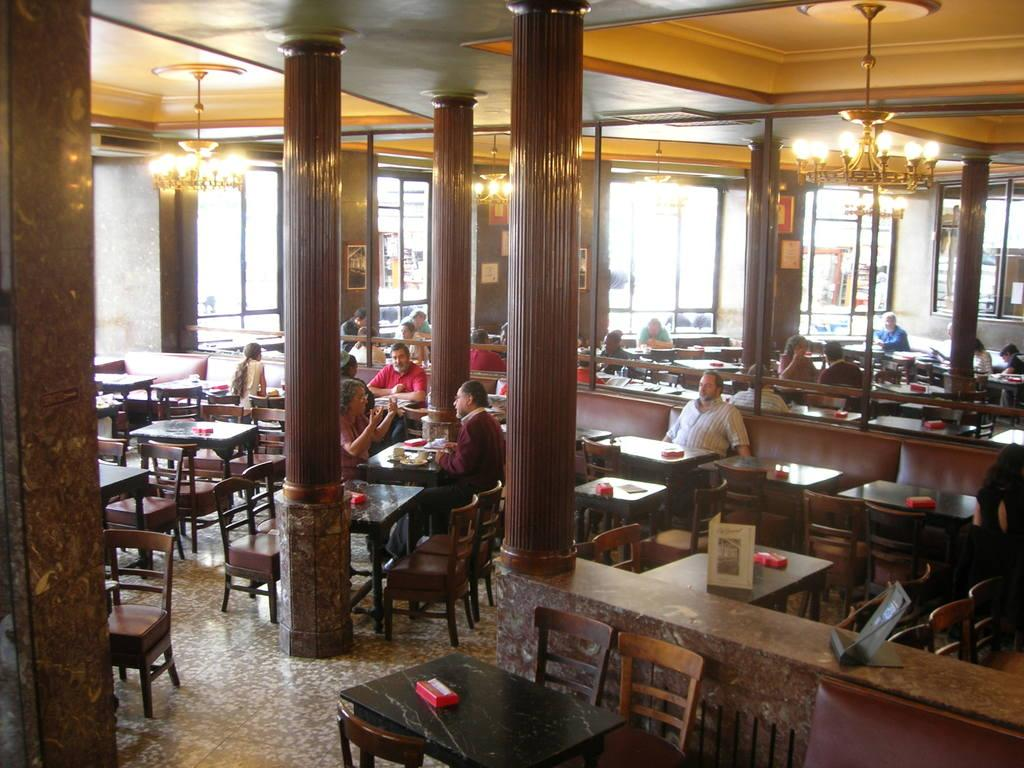What are the persons in the image doing? The persons in the image are sitting in chairs. What can be seen in the background of the image? There are tables in the background. What architectural feature is visible in the image? There is a pillar visible in the image. What is a source of light visible in the image? There is a chandelier visible at the top of the image. Is there any quicksand visible in the image? No, there is no quicksand present in the image. What type of meeting is taking place in the image? There is no indication of a meeting in the image; it simply shows persons sitting in chairs. 